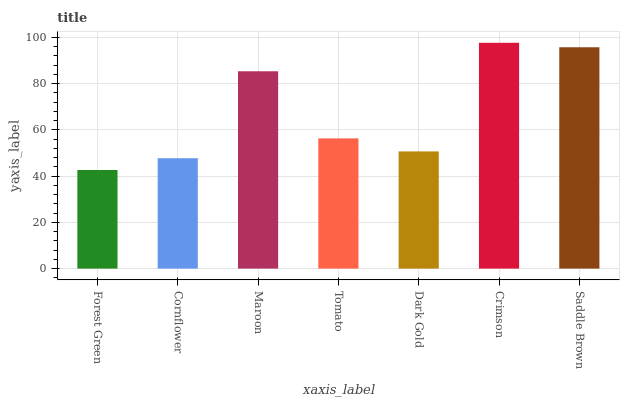Is Cornflower the minimum?
Answer yes or no. No. Is Cornflower the maximum?
Answer yes or no. No. Is Cornflower greater than Forest Green?
Answer yes or no. Yes. Is Forest Green less than Cornflower?
Answer yes or no. Yes. Is Forest Green greater than Cornflower?
Answer yes or no. No. Is Cornflower less than Forest Green?
Answer yes or no. No. Is Tomato the high median?
Answer yes or no. Yes. Is Tomato the low median?
Answer yes or no. Yes. Is Maroon the high median?
Answer yes or no. No. Is Dark Gold the low median?
Answer yes or no. No. 